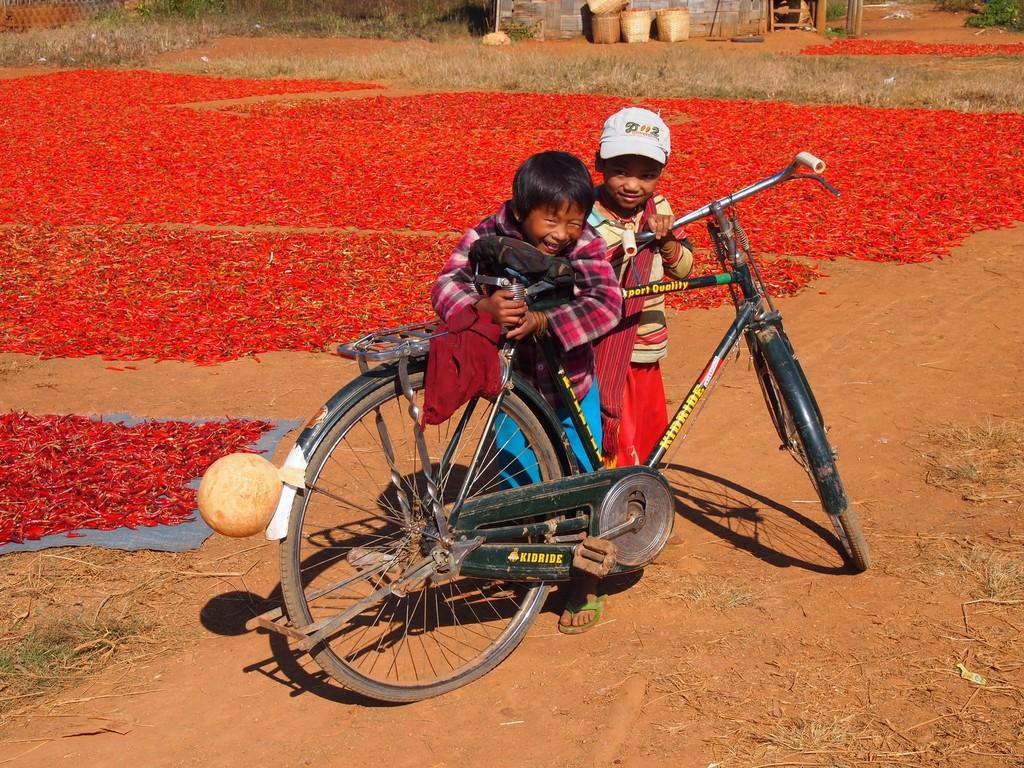What is the main object in the image? There is a cycle in the image. Who is near the cycle? There are two children near the cycle. What can be seen in the background of the image? There are red chillies in the background of the image. What type of vegetation is visible in the image? There is grass visible in the image. How many frogs are sitting on the cycle in the image? There are no frogs present in the image. What type of produce is being sold near the cycle in the image? There is no produce being sold in the image; it only features a cycle, two children, red chillies, and grass. 